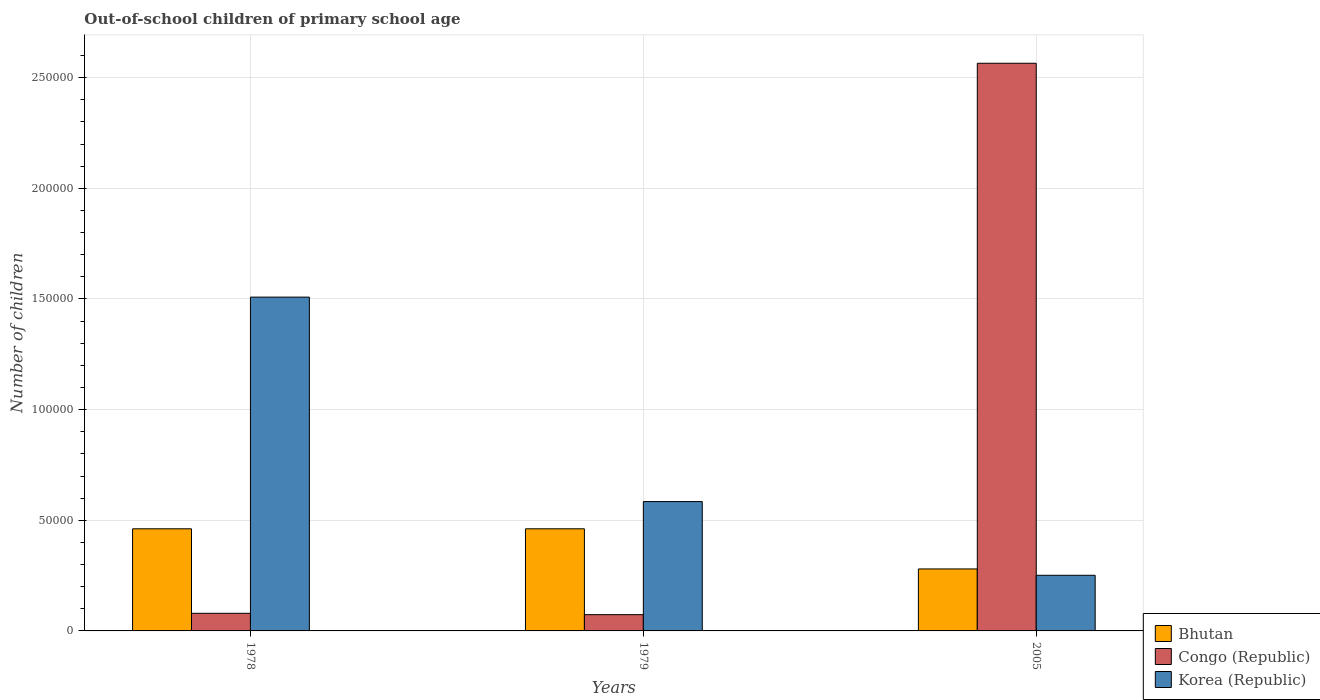How many different coloured bars are there?
Offer a terse response. 3. Are the number of bars on each tick of the X-axis equal?
Ensure brevity in your answer.  Yes. What is the label of the 1st group of bars from the left?
Offer a very short reply. 1978. In how many cases, is the number of bars for a given year not equal to the number of legend labels?
Offer a very short reply. 0. What is the number of out-of-school children in Congo (Republic) in 1979?
Give a very brief answer. 7349. Across all years, what is the maximum number of out-of-school children in Bhutan?
Give a very brief answer. 4.61e+04. Across all years, what is the minimum number of out-of-school children in Korea (Republic)?
Make the answer very short. 2.51e+04. In which year was the number of out-of-school children in Korea (Republic) minimum?
Make the answer very short. 2005. What is the total number of out-of-school children in Congo (Republic) in the graph?
Make the answer very short. 2.72e+05. What is the difference between the number of out-of-school children in Bhutan in 1979 and that in 2005?
Provide a short and direct response. 1.81e+04. What is the difference between the number of out-of-school children in Korea (Republic) in 1978 and the number of out-of-school children in Congo (Republic) in 1979?
Your answer should be very brief. 1.43e+05. What is the average number of out-of-school children in Congo (Republic) per year?
Provide a short and direct response. 9.06e+04. In the year 1979, what is the difference between the number of out-of-school children in Bhutan and number of out-of-school children in Korea (Republic)?
Ensure brevity in your answer.  -1.23e+04. What is the ratio of the number of out-of-school children in Bhutan in 1979 to that in 2005?
Offer a terse response. 1.65. Is the number of out-of-school children in Korea (Republic) in 1978 less than that in 1979?
Your response must be concise. No. What is the difference between the highest and the second highest number of out-of-school children in Congo (Republic)?
Your answer should be compact. 2.49e+05. What is the difference between the highest and the lowest number of out-of-school children in Bhutan?
Make the answer very short. 1.81e+04. What does the 3rd bar from the left in 1979 represents?
Make the answer very short. Korea (Republic). What does the 3rd bar from the right in 1978 represents?
Give a very brief answer. Bhutan. Is it the case that in every year, the sum of the number of out-of-school children in Korea (Republic) and number of out-of-school children in Congo (Republic) is greater than the number of out-of-school children in Bhutan?
Provide a short and direct response. Yes. Are all the bars in the graph horizontal?
Your answer should be compact. No. Does the graph contain grids?
Keep it short and to the point. Yes. Where does the legend appear in the graph?
Provide a succinct answer. Bottom right. How many legend labels are there?
Make the answer very short. 3. How are the legend labels stacked?
Provide a succinct answer. Vertical. What is the title of the graph?
Your answer should be compact. Out-of-school children of primary school age. What is the label or title of the X-axis?
Your response must be concise. Years. What is the label or title of the Y-axis?
Ensure brevity in your answer.  Number of children. What is the Number of children in Bhutan in 1978?
Your answer should be very brief. 4.61e+04. What is the Number of children in Congo (Republic) in 1978?
Your response must be concise. 7961. What is the Number of children of Korea (Republic) in 1978?
Your response must be concise. 1.51e+05. What is the Number of children in Bhutan in 1979?
Provide a short and direct response. 4.61e+04. What is the Number of children of Congo (Republic) in 1979?
Ensure brevity in your answer.  7349. What is the Number of children of Korea (Republic) in 1979?
Offer a very short reply. 5.85e+04. What is the Number of children in Bhutan in 2005?
Make the answer very short. 2.80e+04. What is the Number of children in Congo (Republic) in 2005?
Your response must be concise. 2.57e+05. What is the Number of children in Korea (Republic) in 2005?
Offer a terse response. 2.51e+04. Across all years, what is the maximum Number of children in Bhutan?
Provide a succinct answer. 4.61e+04. Across all years, what is the maximum Number of children in Congo (Republic)?
Make the answer very short. 2.57e+05. Across all years, what is the maximum Number of children in Korea (Republic)?
Your answer should be very brief. 1.51e+05. Across all years, what is the minimum Number of children in Bhutan?
Keep it short and to the point. 2.80e+04. Across all years, what is the minimum Number of children of Congo (Republic)?
Offer a terse response. 7349. Across all years, what is the minimum Number of children of Korea (Republic)?
Offer a terse response. 2.51e+04. What is the total Number of children in Bhutan in the graph?
Make the answer very short. 1.20e+05. What is the total Number of children in Congo (Republic) in the graph?
Ensure brevity in your answer.  2.72e+05. What is the total Number of children in Korea (Republic) in the graph?
Your answer should be compact. 2.34e+05. What is the difference between the Number of children of Congo (Republic) in 1978 and that in 1979?
Your response must be concise. 612. What is the difference between the Number of children of Korea (Republic) in 1978 and that in 1979?
Offer a very short reply. 9.24e+04. What is the difference between the Number of children in Bhutan in 1978 and that in 2005?
Your answer should be very brief. 1.81e+04. What is the difference between the Number of children in Congo (Republic) in 1978 and that in 2005?
Provide a succinct answer. -2.49e+05. What is the difference between the Number of children in Korea (Republic) in 1978 and that in 2005?
Your answer should be very brief. 1.26e+05. What is the difference between the Number of children of Bhutan in 1979 and that in 2005?
Ensure brevity in your answer.  1.81e+04. What is the difference between the Number of children in Congo (Republic) in 1979 and that in 2005?
Your response must be concise. -2.49e+05. What is the difference between the Number of children in Korea (Republic) in 1979 and that in 2005?
Give a very brief answer. 3.33e+04. What is the difference between the Number of children in Bhutan in 1978 and the Number of children in Congo (Republic) in 1979?
Ensure brevity in your answer.  3.88e+04. What is the difference between the Number of children of Bhutan in 1978 and the Number of children of Korea (Republic) in 1979?
Provide a succinct answer. -1.23e+04. What is the difference between the Number of children of Congo (Republic) in 1978 and the Number of children of Korea (Republic) in 1979?
Offer a terse response. -5.05e+04. What is the difference between the Number of children in Bhutan in 1978 and the Number of children in Congo (Republic) in 2005?
Make the answer very short. -2.10e+05. What is the difference between the Number of children of Bhutan in 1978 and the Number of children of Korea (Republic) in 2005?
Provide a succinct answer. 2.10e+04. What is the difference between the Number of children of Congo (Republic) in 1978 and the Number of children of Korea (Republic) in 2005?
Provide a succinct answer. -1.72e+04. What is the difference between the Number of children of Bhutan in 1979 and the Number of children of Congo (Republic) in 2005?
Make the answer very short. -2.10e+05. What is the difference between the Number of children in Bhutan in 1979 and the Number of children in Korea (Republic) in 2005?
Your answer should be compact. 2.10e+04. What is the difference between the Number of children in Congo (Republic) in 1979 and the Number of children in Korea (Republic) in 2005?
Provide a succinct answer. -1.78e+04. What is the average Number of children in Bhutan per year?
Offer a very short reply. 4.01e+04. What is the average Number of children in Congo (Republic) per year?
Provide a succinct answer. 9.06e+04. What is the average Number of children in Korea (Republic) per year?
Give a very brief answer. 7.81e+04. In the year 1978, what is the difference between the Number of children in Bhutan and Number of children in Congo (Republic)?
Your response must be concise. 3.82e+04. In the year 1978, what is the difference between the Number of children of Bhutan and Number of children of Korea (Republic)?
Your answer should be compact. -1.05e+05. In the year 1978, what is the difference between the Number of children of Congo (Republic) and Number of children of Korea (Republic)?
Provide a succinct answer. -1.43e+05. In the year 1979, what is the difference between the Number of children of Bhutan and Number of children of Congo (Republic)?
Provide a short and direct response. 3.88e+04. In the year 1979, what is the difference between the Number of children of Bhutan and Number of children of Korea (Republic)?
Provide a short and direct response. -1.23e+04. In the year 1979, what is the difference between the Number of children of Congo (Republic) and Number of children of Korea (Republic)?
Offer a terse response. -5.11e+04. In the year 2005, what is the difference between the Number of children in Bhutan and Number of children in Congo (Republic)?
Give a very brief answer. -2.29e+05. In the year 2005, what is the difference between the Number of children in Bhutan and Number of children in Korea (Republic)?
Your answer should be very brief. 2870. In the year 2005, what is the difference between the Number of children in Congo (Republic) and Number of children in Korea (Republic)?
Your answer should be very brief. 2.31e+05. What is the ratio of the Number of children of Bhutan in 1978 to that in 1979?
Offer a terse response. 1. What is the ratio of the Number of children in Korea (Republic) in 1978 to that in 1979?
Your response must be concise. 2.58. What is the ratio of the Number of children in Bhutan in 1978 to that in 2005?
Your response must be concise. 1.65. What is the ratio of the Number of children of Congo (Republic) in 1978 to that in 2005?
Provide a short and direct response. 0.03. What is the ratio of the Number of children in Korea (Republic) in 1978 to that in 2005?
Make the answer very short. 6. What is the ratio of the Number of children of Bhutan in 1979 to that in 2005?
Offer a very short reply. 1.65. What is the ratio of the Number of children in Congo (Republic) in 1979 to that in 2005?
Your response must be concise. 0.03. What is the ratio of the Number of children of Korea (Republic) in 1979 to that in 2005?
Keep it short and to the point. 2.33. What is the difference between the highest and the second highest Number of children of Congo (Republic)?
Give a very brief answer. 2.49e+05. What is the difference between the highest and the second highest Number of children in Korea (Republic)?
Make the answer very short. 9.24e+04. What is the difference between the highest and the lowest Number of children of Bhutan?
Provide a short and direct response. 1.81e+04. What is the difference between the highest and the lowest Number of children in Congo (Republic)?
Your response must be concise. 2.49e+05. What is the difference between the highest and the lowest Number of children of Korea (Republic)?
Your response must be concise. 1.26e+05. 